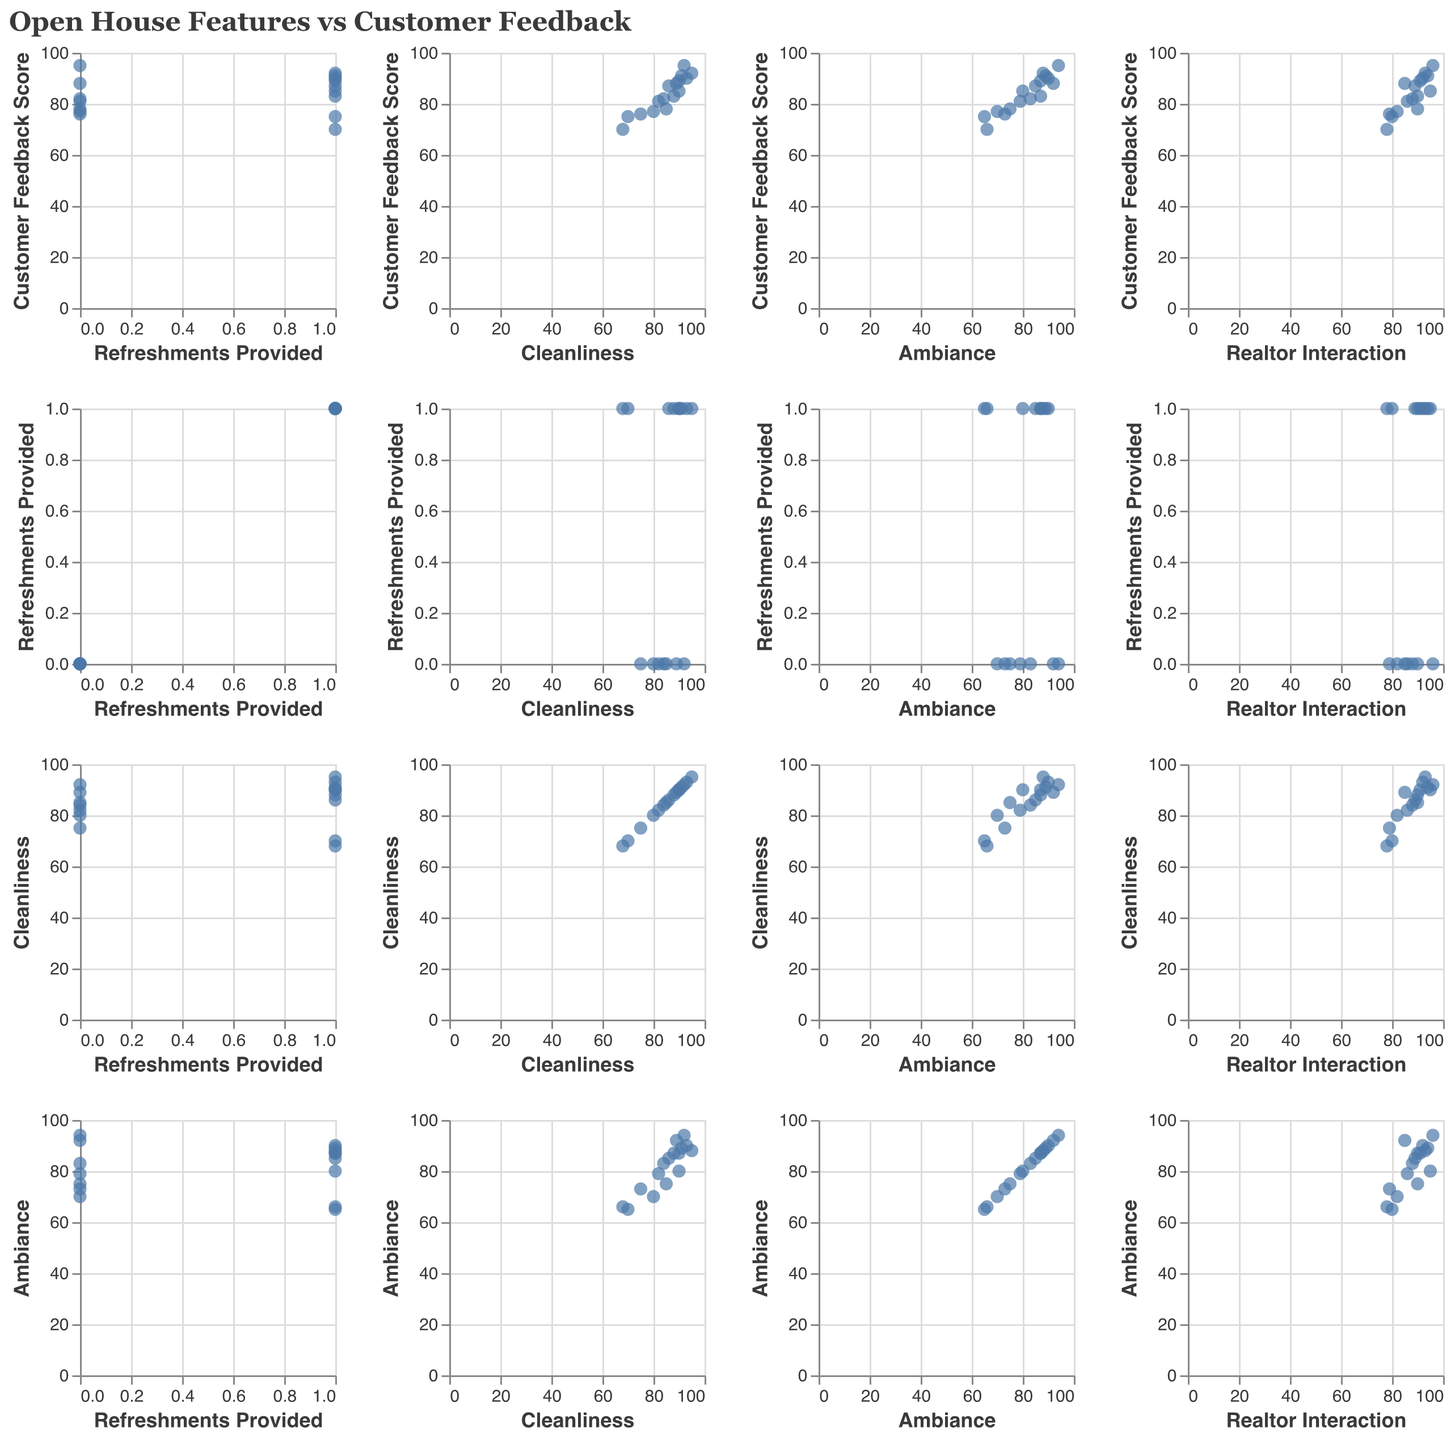What is the title of the figure? The title of the figure is displayed at the top and reads "Open House Features vs Customer Feedback".
Answer: Open House Features vs Customer Feedback How many dimensions are plotted along each row and column? Each row and column in the Scatter Plot Matrix represents 4 dimensions: Customer Feedback Score, Refreshments Provided, Cleanliness, and Ambiance for the rows, and Refreshments Provided, Cleanliness, Ambiance, and Realtor Interaction for the columns.
Answer: 4 Is there a positive relationship between Cleanliness and Customer Feedback Score? By looking at the SPLOM, you can see the scatter plot for Cleanliness vs Customer Feedback Score where the data points seem to form an upward trend, indicating a positive relationship.
Answer: Yes Which two features seem to have the strongest positive correlation based on visual inspection? Based on visual inspection, the strongest positive correlation appears to be between Cleanliness and Ambiance, as the data points for this pair are tightly clustered along a slanting line.
Answer: Cleanliness and Ambiance Do Open Houses with refreshments provided generally have higher Customer Feedback Scores? To determine this, look at the scatter plots involving Customer Feedback Scores and the binary indicator Refreshments Provided. Generally, points with Refreshments Provided (1) tend to have higher Customer Feedback Scores than those without (0).
Answer: Yes Are there any data points where high Cleanliness scores do not correspond to high Customer Feedback scores? There are a few points where Cleanliness scores are high (above 85) but Customer Feedback scores are not as high, indicating that high Cleanliness does not always lead to high Customer Feedback. For example, a Cleanliness score of 95 corresponds with a Customer Feedback score of 75.
Answer: Yes What is the relationship between Realtor Interaction and Customer Feedback Score? The scatter plot of Realtor Interaction vs Customer Feedback Score shows a generally positive trend, indicating that better Realtor Interaction tends to be associated with higher Customer Feedback Scores.
Answer: Positive relationship From the SPLOM, can you identify any outliers in the data? Outliers can be identified where data points significantly deviate from the general trend. For example, a data point with high Cleanliness (~95) but relatively low Customer Feedback score (~75) could be considered an outlier.
Answer: Yes, for example, a point with Cleanliness ~95 and Customer Feedback score ~75 What would be the expected trend of Ambiance and Customer Feedback Score? By examining the scatter plot of Ambiance vs Customer Feedback Score in the SPLOM, you can see a positive trend where higher Ambiance scores correspond to higher Customer Feedback Scores.
Answer: Positive trend 